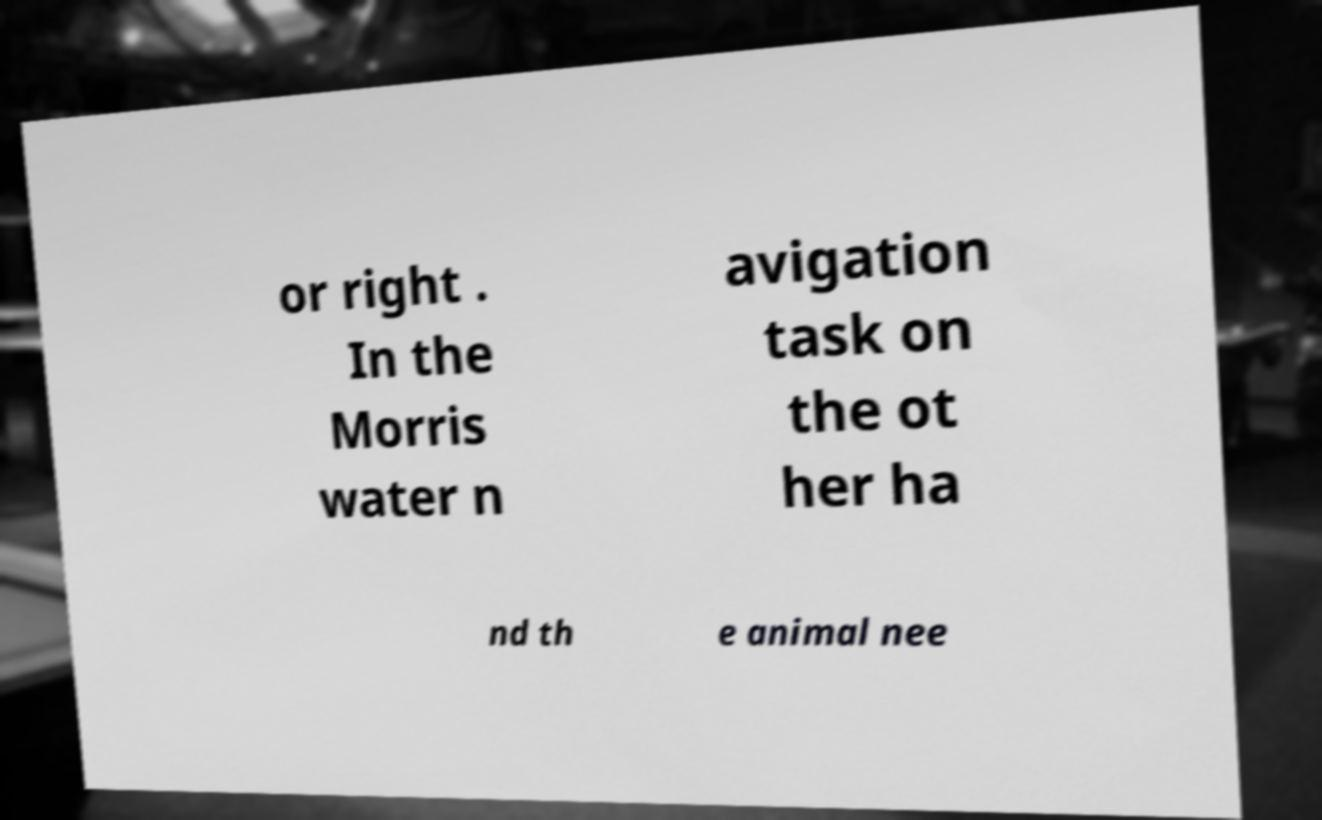Could you extract and type out the text from this image? or right . In the Morris water n avigation task on the ot her ha nd th e animal nee 